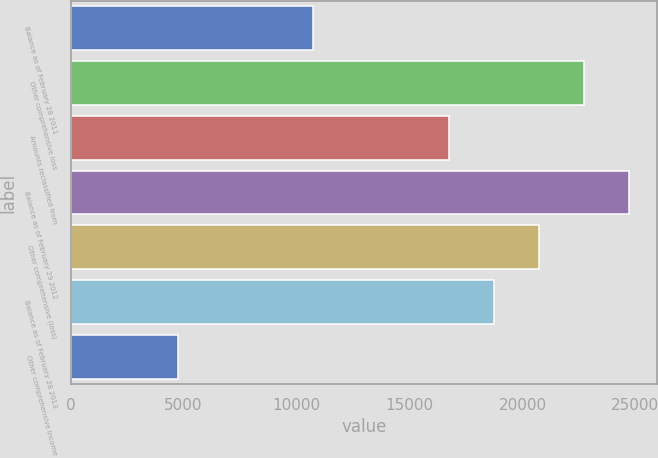<chart> <loc_0><loc_0><loc_500><loc_500><bar_chart><fcel>Balance as of February 28 2011<fcel>Other comprehensive loss<fcel>Amounts reclassified from<fcel>Balance as of February 29 2012<fcel>Other comprehensive (loss)<fcel>Balance as of February 28 2013<fcel>Other comprehensive income<nl><fcel>10753<fcel>22723<fcel>16738<fcel>24718<fcel>20728<fcel>18733<fcel>4768<nl></chart> 